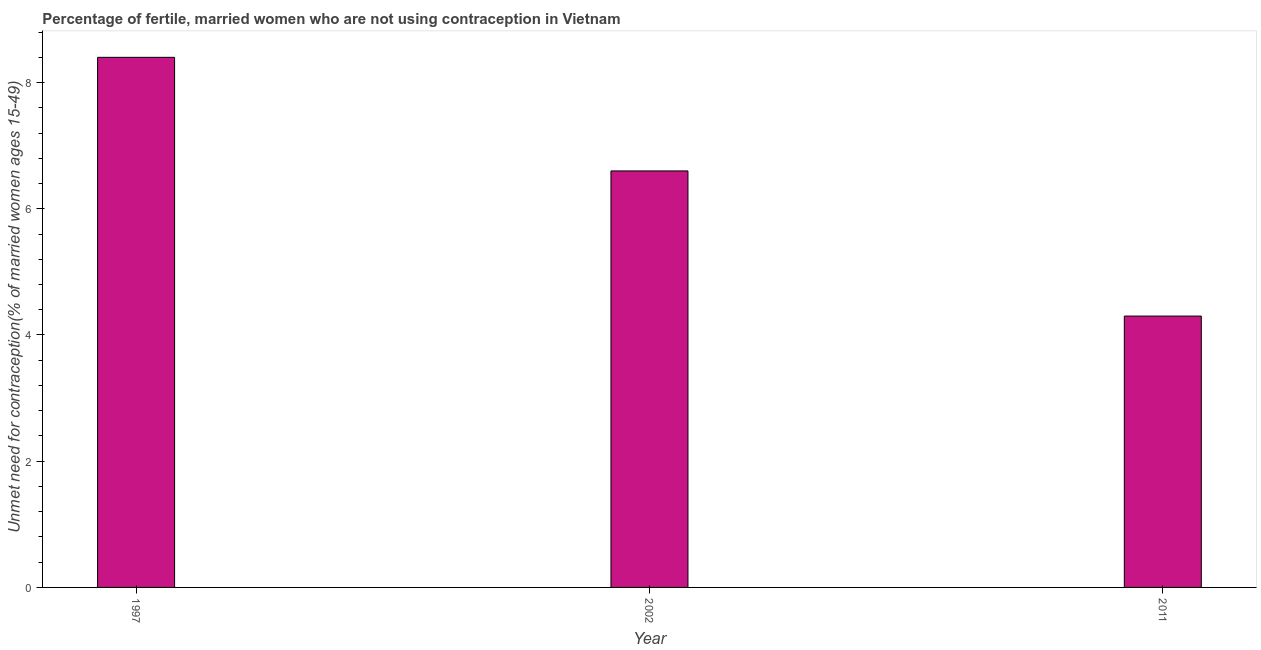Does the graph contain any zero values?
Provide a succinct answer. No. Does the graph contain grids?
Ensure brevity in your answer.  No. What is the title of the graph?
Make the answer very short. Percentage of fertile, married women who are not using contraception in Vietnam. What is the label or title of the X-axis?
Ensure brevity in your answer.  Year. What is the label or title of the Y-axis?
Keep it short and to the point.  Unmet need for contraception(% of married women ages 15-49). Across all years, what is the maximum number of married women who are not using contraception?
Offer a terse response. 8.4. What is the sum of the number of married women who are not using contraception?
Your response must be concise. 19.3. What is the average number of married women who are not using contraception per year?
Ensure brevity in your answer.  6.43. What is the median number of married women who are not using contraception?
Your response must be concise. 6.6. In how many years, is the number of married women who are not using contraception greater than 1.6 %?
Ensure brevity in your answer.  3. What is the ratio of the number of married women who are not using contraception in 1997 to that in 2011?
Offer a terse response. 1.95. Is the number of married women who are not using contraception in 2002 less than that in 2011?
Provide a short and direct response. No. Is the sum of the number of married women who are not using contraception in 2002 and 2011 greater than the maximum number of married women who are not using contraception across all years?
Keep it short and to the point. Yes. How many bars are there?
Offer a terse response. 3. What is the difference between two consecutive major ticks on the Y-axis?
Offer a very short reply. 2. What is the  Unmet need for contraception(% of married women ages 15-49) in 1997?
Give a very brief answer. 8.4. What is the  Unmet need for contraception(% of married women ages 15-49) in 2002?
Make the answer very short. 6.6. What is the difference between the  Unmet need for contraception(% of married women ages 15-49) in 1997 and 2002?
Offer a terse response. 1.8. What is the ratio of the  Unmet need for contraception(% of married women ages 15-49) in 1997 to that in 2002?
Provide a short and direct response. 1.27. What is the ratio of the  Unmet need for contraception(% of married women ages 15-49) in 1997 to that in 2011?
Your answer should be very brief. 1.95. What is the ratio of the  Unmet need for contraception(% of married women ages 15-49) in 2002 to that in 2011?
Ensure brevity in your answer.  1.53. 